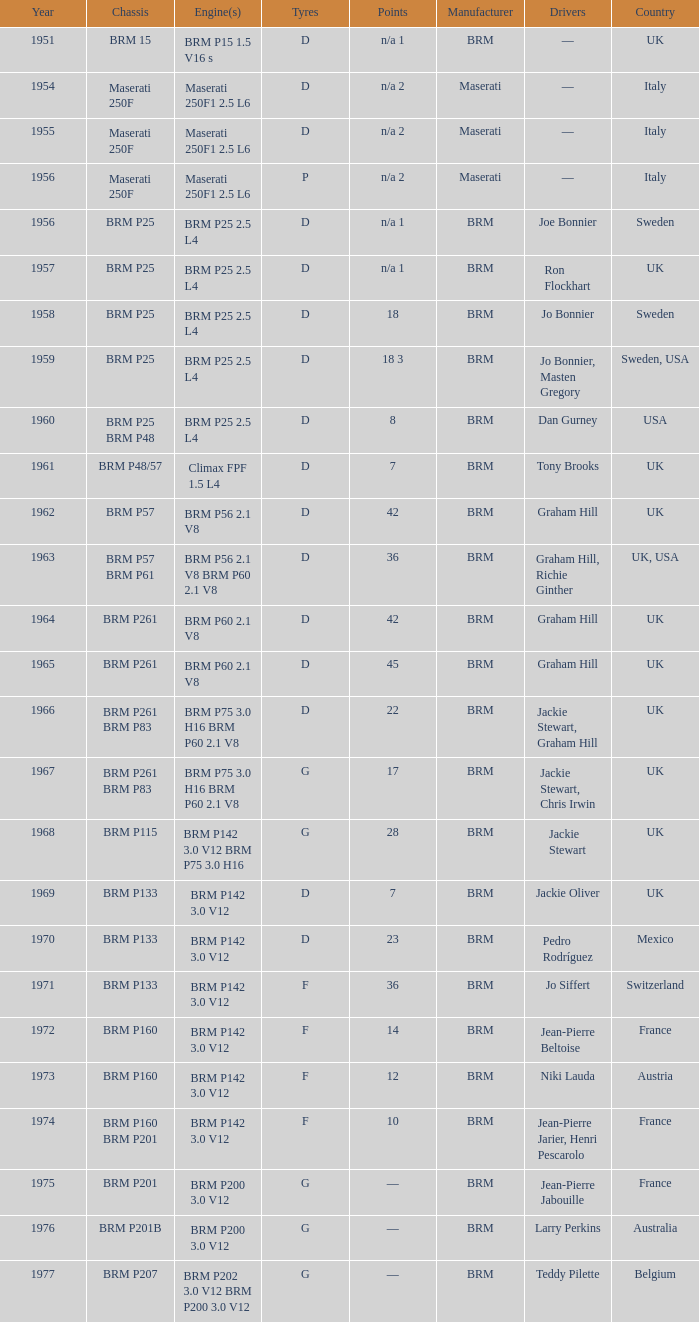Determine the combined years of brm p202 1977.0. 